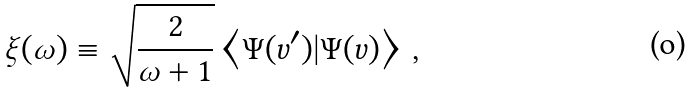Convert formula to latex. <formula><loc_0><loc_0><loc_500><loc_500>\xi ( \omega ) \equiv \sqrt { \frac { 2 } { \omega + 1 } } \left < \Psi ( v ^ { \prime } ) | \Psi ( v ) \right > \, ,</formula> 